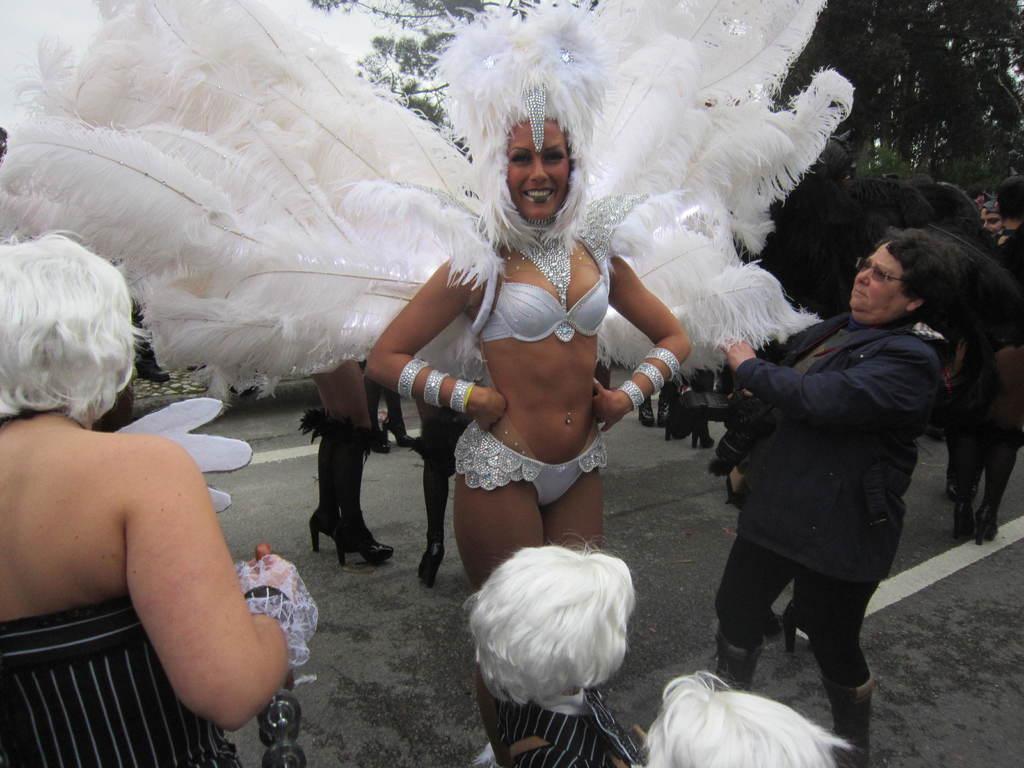Please provide a concise description of this image. In this picture we can see a group of people standing on the road were a woman wore a fancy dress and smiling and in the background we can see trees, sky. 